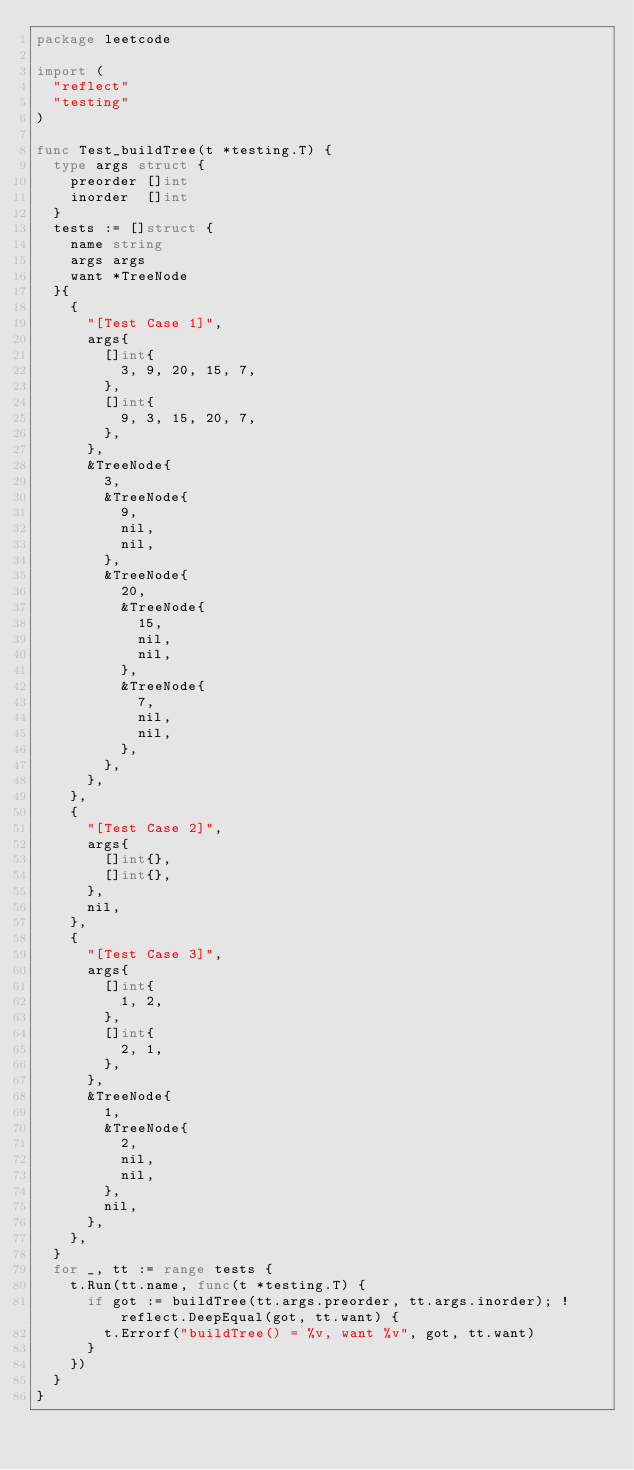Convert code to text. <code><loc_0><loc_0><loc_500><loc_500><_Go_>package leetcode

import (
	"reflect"
	"testing"
)

func Test_buildTree(t *testing.T) {
	type args struct {
		preorder []int
		inorder  []int
	}
	tests := []struct {
		name string
		args args
		want *TreeNode
	}{
		{
			"[Test Case 1]",
			args{
				[]int{
					3, 9, 20, 15, 7,
				},
				[]int{
					9, 3, 15, 20, 7,
				},
			},
			&TreeNode{
				3,
				&TreeNode{
					9,
					nil,
					nil,
				},
				&TreeNode{
					20,
					&TreeNode{
						15,
						nil,
						nil,
					},
					&TreeNode{
						7,
						nil,
						nil,
					},
				},
			},
		},
		{
			"[Test Case 2]",
			args{
				[]int{},
				[]int{},
			},
			nil,
		},
		{
			"[Test Case 3]",
			args{
				[]int{
					1, 2,
				},
				[]int{
					2, 1,
				},
			},
			&TreeNode{
				1,
				&TreeNode{
					2,
					nil,
					nil,
				},
				nil,
			},
		},
	}
	for _, tt := range tests {
		t.Run(tt.name, func(t *testing.T) {
			if got := buildTree(tt.args.preorder, tt.args.inorder); !reflect.DeepEqual(got, tt.want) {
				t.Errorf("buildTree() = %v, want %v", got, tt.want)
			}
		})
	}
}
</code> 